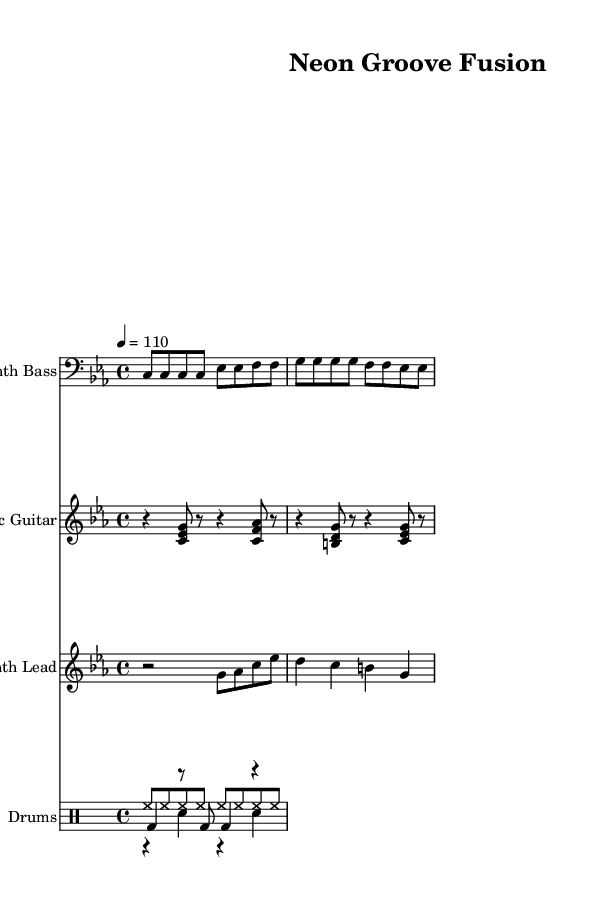what is the key signature of this music? The key signature is C minor, which has three flats (B, E, and A). This can be determined by looking at the key signature at the beginning of the staff, which indicates the tonal center of the piece.
Answer: C minor what is the time signature of this music? The time signature is 4/4, which means there are four beats in a measure and a quarter note gets one beat. This can be observed just after the key signature in the initial measure.
Answer: 4/4 what is the tempo marking of this music? The tempo marking is 110 beats per minute, indicated by the tempo instruction "4 = 110." This means that a quarter note should be played at a speed of 110 beats per minute.
Answer: 110 how many staves are used in this music? There are four staves visible in the score: one for Synth Bass, one for Electric Guitar, one for Synth Lead, and one for Drums. Each staff is labeled with the respective instrument names, contributing to the orchestration of the piece.
Answer: 4 which instrument plays a bass line? The instrument playing the bass line is the Synth Bass, indicated by the notation written in the bass clef staff. This is typically where bass instruments are notated, differentiating them from higher-pitched instruments.
Answer: Synth Bass how many different drum voices are there, and what are they? There are three different drum voices: hi-hat, snare, and kick. Each is notated in separate drum voices within the DrumStaff, clearly distinguishing their rhythmic contributions to the overall groove.
Answer: Hi-hat, Snare, Kick what is the primary style implemented in this piece, based on instrumentation? The primary style is Funk, characterized by its strong bass lines, rhythmic guitar riffs, and syncopated drumming patterns that are typical of this genre. The arrangement of electronic and funk elements also suggests a fusion of styles.
Answer: Funk 